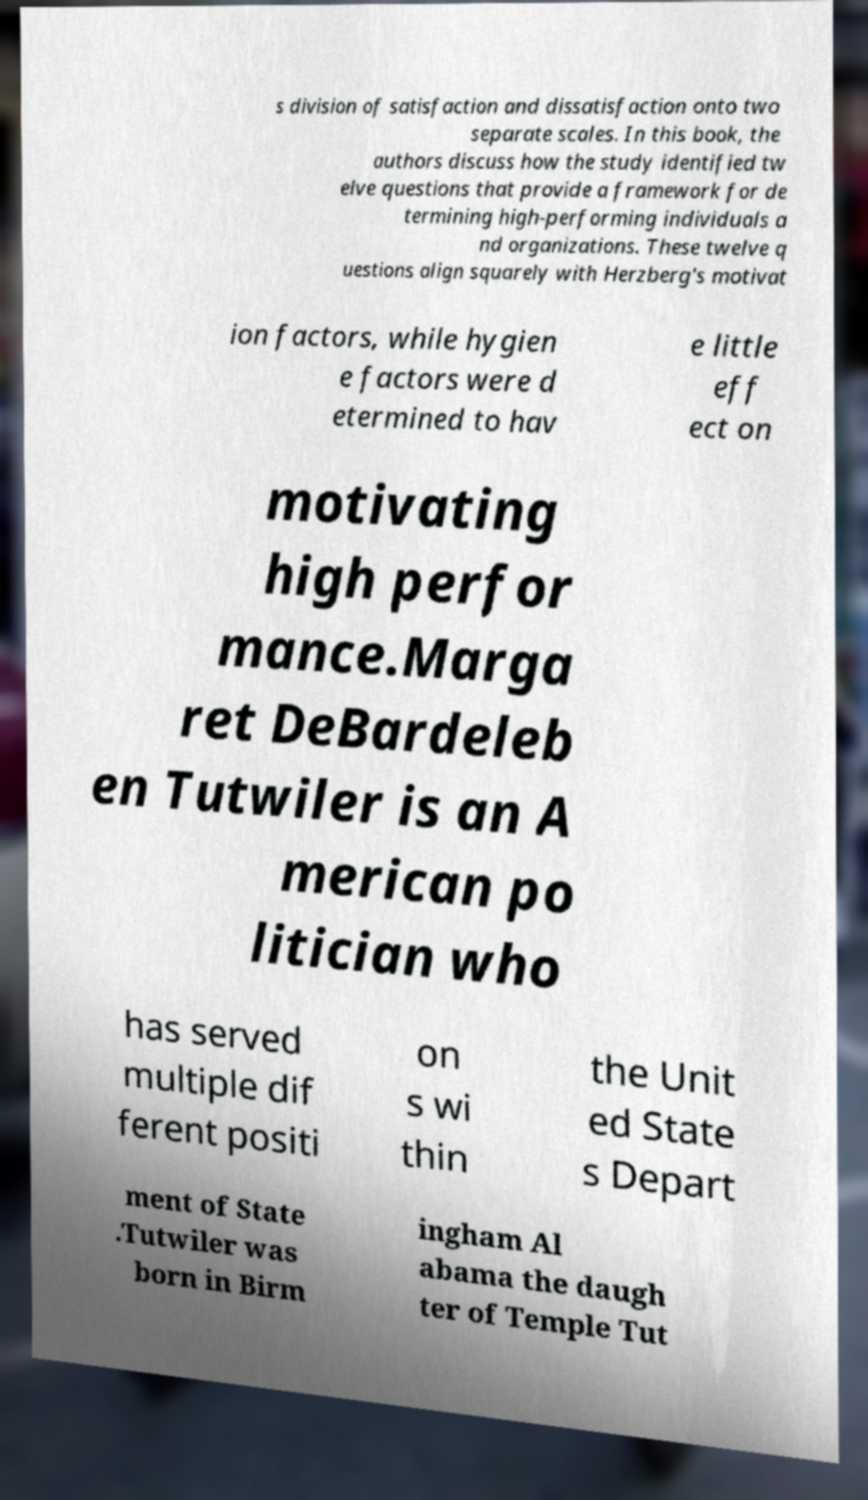Please identify and transcribe the text found in this image. s division of satisfaction and dissatisfaction onto two separate scales. In this book, the authors discuss how the study identified tw elve questions that provide a framework for de termining high-performing individuals a nd organizations. These twelve q uestions align squarely with Herzberg's motivat ion factors, while hygien e factors were d etermined to hav e little eff ect on motivating high perfor mance.Marga ret DeBardeleb en Tutwiler is an A merican po litician who has served multiple dif ferent positi on s wi thin the Unit ed State s Depart ment of State .Tutwiler was born in Birm ingham Al abama the daugh ter of Temple Tut 